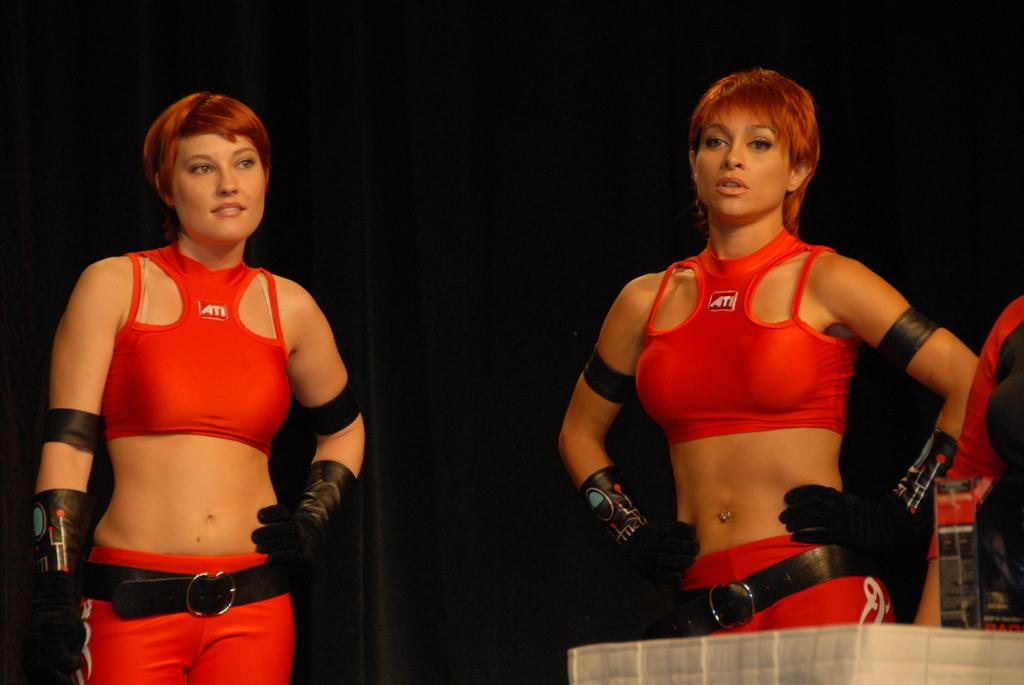<image>
Present a compact description of the photo's key features. Two women in red uniforms of spandex for ATL stand waiting. 